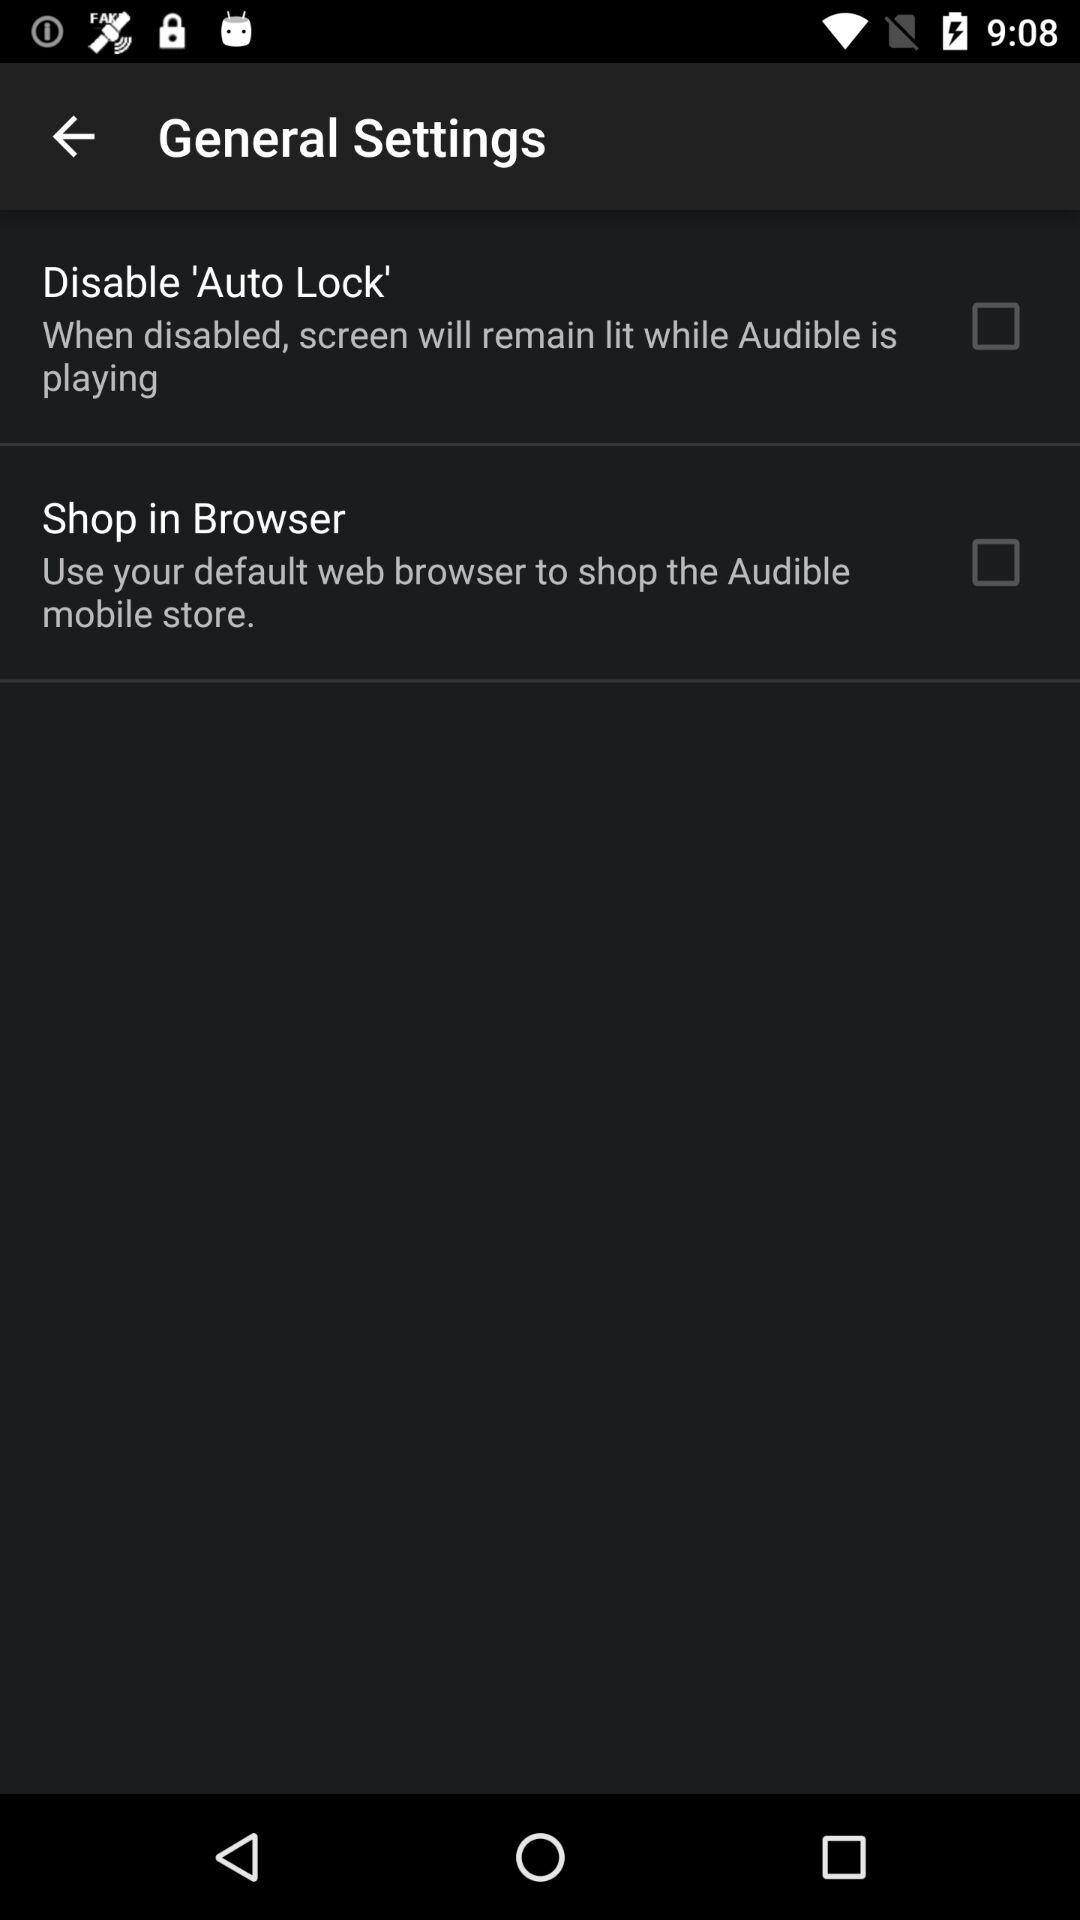What is the status of "Shop in Browser"? The status is "off". 